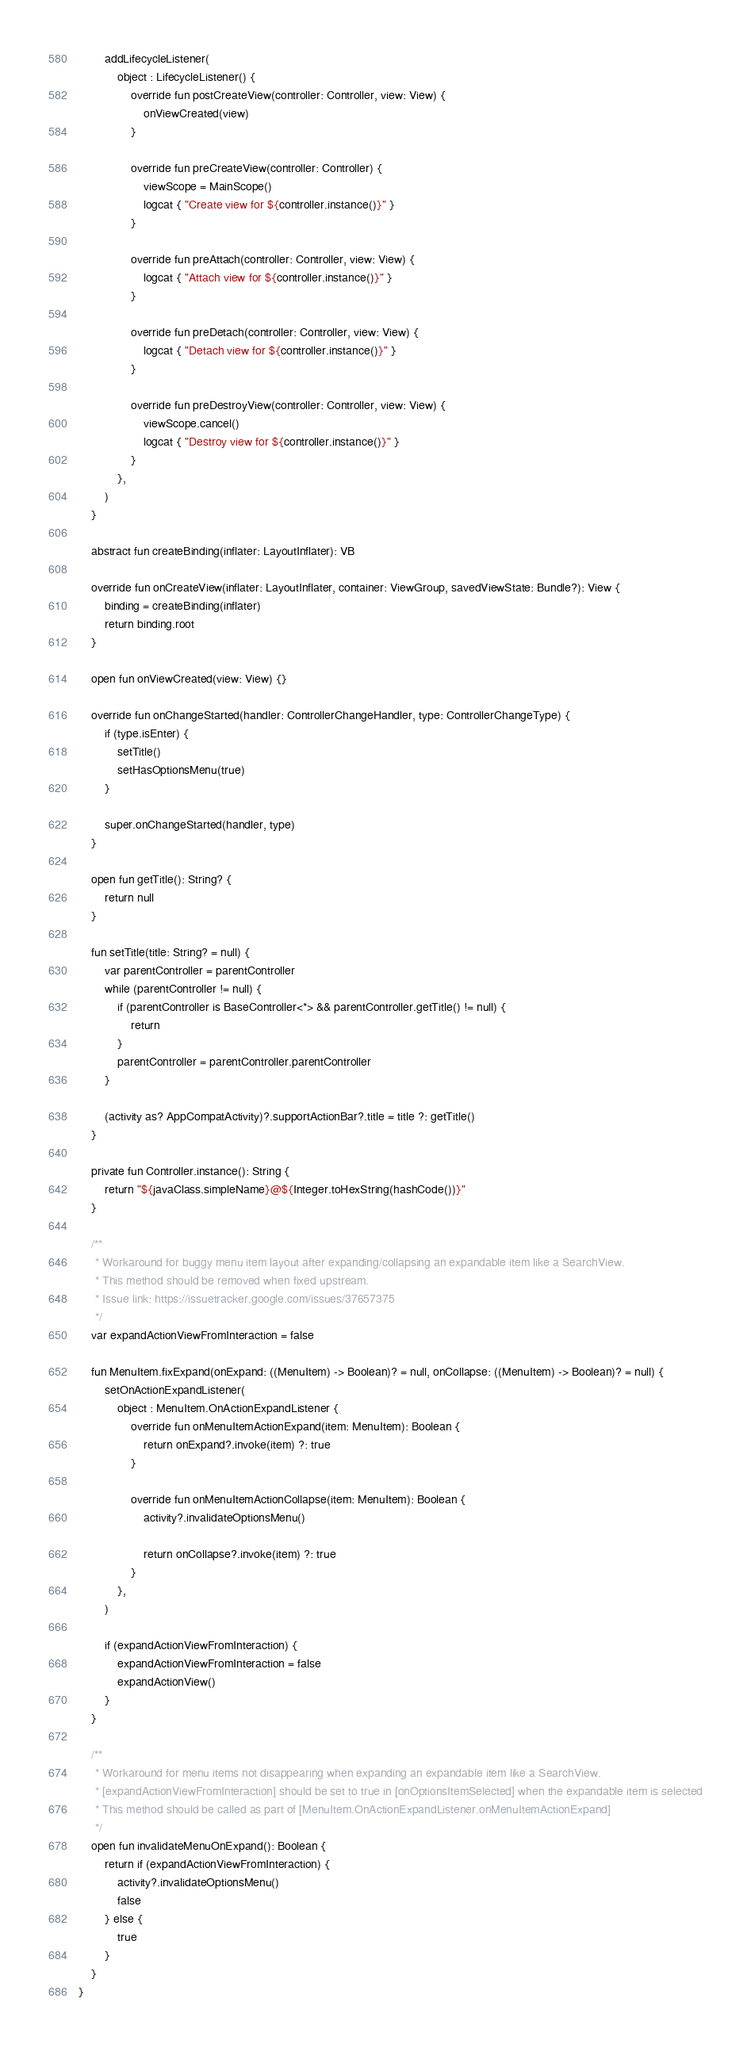Convert code to text. <code><loc_0><loc_0><loc_500><loc_500><_Kotlin_>        addLifecycleListener(
            object : LifecycleListener() {
                override fun postCreateView(controller: Controller, view: View) {
                    onViewCreated(view)
                }

                override fun preCreateView(controller: Controller) {
                    viewScope = MainScope()
                    logcat { "Create view for ${controller.instance()}" }
                }

                override fun preAttach(controller: Controller, view: View) {
                    logcat { "Attach view for ${controller.instance()}" }
                }

                override fun preDetach(controller: Controller, view: View) {
                    logcat { "Detach view for ${controller.instance()}" }
                }

                override fun preDestroyView(controller: Controller, view: View) {
                    viewScope.cancel()
                    logcat { "Destroy view for ${controller.instance()}" }
                }
            },
        )
    }

    abstract fun createBinding(inflater: LayoutInflater): VB

    override fun onCreateView(inflater: LayoutInflater, container: ViewGroup, savedViewState: Bundle?): View {
        binding = createBinding(inflater)
        return binding.root
    }

    open fun onViewCreated(view: View) {}

    override fun onChangeStarted(handler: ControllerChangeHandler, type: ControllerChangeType) {
        if (type.isEnter) {
            setTitle()
            setHasOptionsMenu(true)
        }

        super.onChangeStarted(handler, type)
    }

    open fun getTitle(): String? {
        return null
    }

    fun setTitle(title: String? = null) {
        var parentController = parentController
        while (parentController != null) {
            if (parentController is BaseController<*> && parentController.getTitle() != null) {
                return
            }
            parentController = parentController.parentController
        }

        (activity as? AppCompatActivity)?.supportActionBar?.title = title ?: getTitle()
    }

    private fun Controller.instance(): String {
        return "${javaClass.simpleName}@${Integer.toHexString(hashCode())}"
    }

    /**
     * Workaround for buggy menu item layout after expanding/collapsing an expandable item like a SearchView.
     * This method should be removed when fixed upstream.
     * Issue link: https://issuetracker.google.com/issues/37657375
     */
    var expandActionViewFromInteraction = false

    fun MenuItem.fixExpand(onExpand: ((MenuItem) -> Boolean)? = null, onCollapse: ((MenuItem) -> Boolean)? = null) {
        setOnActionExpandListener(
            object : MenuItem.OnActionExpandListener {
                override fun onMenuItemActionExpand(item: MenuItem): Boolean {
                    return onExpand?.invoke(item) ?: true
                }

                override fun onMenuItemActionCollapse(item: MenuItem): Boolean {
                    activity?.invalidateOptionsMenu()

                    return onCollapse?.invoke(item) ?: true
                }
            },
        )

        if (expandActionViewFromInteraction) {
            expandActionViewFromInteraction = false
            expandActionView()
        }
    }

    /**
     * Workaround for menu items not disappearing when expanding an expandable item like a SearchView.
     * [expandActionViewFromInteraction] should be set to true in [onOptionsItemSelected] when the expandable item is selected
     * This method should be called as part of [MenuItem.OnActionExpandListener.onMenuItemActionExpand]
     */
    open fun invalidateMenuOnExpand(): Boolean {
        return if (expandActionViewFromInteraction) {
            activity?.invalidateOptionsMenu()
            false
        } else {
            true
        }
    }
}
</code> 